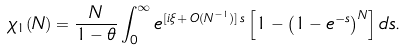<formula> <loc_0><loc_0><loc_500><loc_500>\chi _ { 1 } ( N ) = \frac { N } { 1 - \theta } \int _ { 0 } ^ { \infty } e ^ { [ i \xi \, + \, O ( N ^ { - 1 } ) ] \, s } \left [ 1 - \left ( 1 - e ^ { - s } \right ) ^ { N } \right ] d s .</formula> 